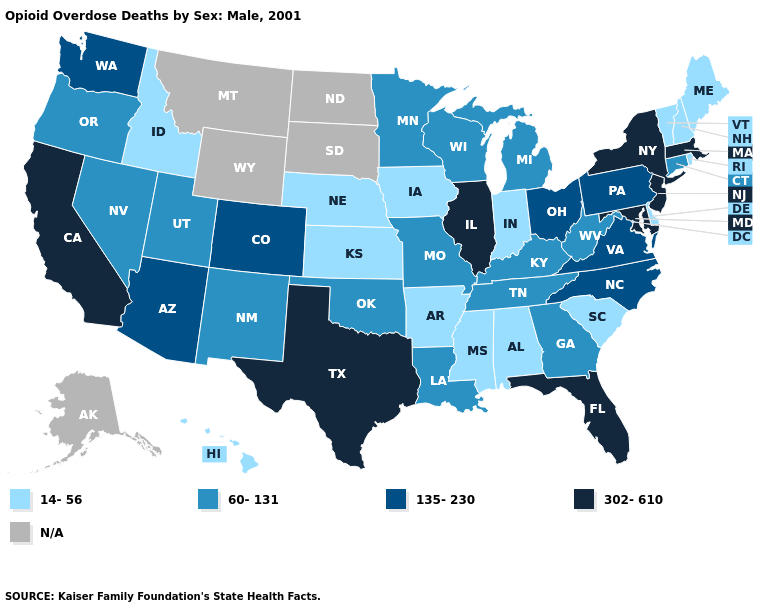Does California have the highest value in the West?
Keep it brief. Yes. Name the states that have a value in the range 14-56?
Quick response, please. Alabama, Arkansas, Delaware, Hawaii, Idaho, Indiana, Iowa, Kansas, Maine, Mississippi, Nebraska, New Hampshire, Rhode Island, South Carolina, Vermont. Does Georgia have the highest value in the South?
Concise answer only. No. How many symbols are there in the legend?
Be succinct. 5. Name the states that have a value in the range N/A?
Concise answer only. Alaska, Montana, North Dakota, South Dakota, Wyoming. What is the value of Iowa?
Be succinct. 14-56. What is the value of Mississippi?
Keep it brief. 14-56. What is the lowest value in states that border Washington?
Keep it brief. 14-56. What is the value of Delaware?
Give a very brief answer. 14-56. Name the states that have a value in the range 302-610?
Be succinct. California, Florida, Illinois, Maryland, Massachusetts, New Jersey, New York, Texas. Name the states that have a value in the range 60-131?
Short answer required. Connecticut, Georgia, Kentucky, Louisiana, Michigan, Minnesota, Missouri, Nevada, New Mexico, Oklahoma, Oregon, Tennessee, Utah, West Virginia, Wisconsin. What is the highest value in the USA?
Write a very short answer. 302-610. Among the states that border California , which have the highest value?
Concise answer only. Arizona. 